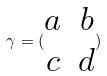<formula> <loc_0><loc_0><loc_500><loc_500>\gamma = ( \begin{matrix} a & b \\ c & d \end{matrix} )</formula> 